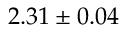Convert formula to latex. <formula><loc_0><loc_0><loc_500><loc_500>2 . 3 1 \pm 0 . 0 4</formula> 